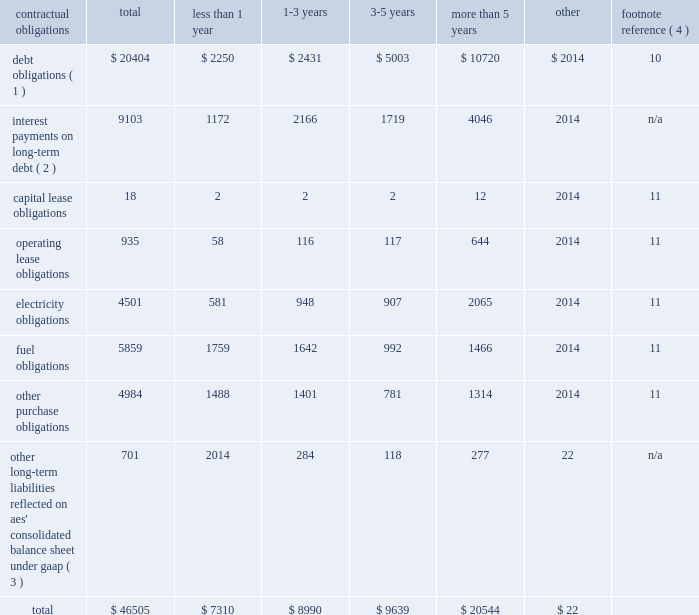2022 triggering our obligation to make payments under any financial guarantee , letter of credit or other credit support we have provided to or on behalf of such subsidiary ; 2022 causing us to record a loss in the event the lender forecloses on the assets ; and 2022 triggering defaults in our outstanding debt at the parent company .
For example , our senior secured credit facility and outstanding debt securities at the parent company include events of default for certain bankruptcy related events involving material subsidiaries .
In addition , our revolving credit agreement at the parent company includes events of default related to payment defaults and accelerations of outstanding debt of material subsidiaries .
Some of our subsidiaries are currently in default with respect to all or a portion of their outstanding indebtedness .
The total non-recourse debt classified as current in the accompanying consolidated balance sheets amounts to $ 2.2 billion .
The portion of current debt related to such defaults was $ 1 billion at december 31 , 2017 , all of which was non-recourse debt related to three subsidiaries 2014 alto maipo , aes puerto rico , and aes ilumina .
See note 10 2014debt in item 8 . 2014financial statements and supplementary data of this form 10-k for additional detail .
None of the subsidiaries that are currently in default are subsidiaries that met the applicable definition of materiality under aes' corporate debt agreements as of december 31 , 2017 in order for such defaults to trigger an event of default or permit acceleration under aes' indebtedness .
However , as a result of additional dispositions of assets , other significant reductions in asset carrying values or other matters in the future that may impact our financial position and results of operations or the financial position of the individual subsidiary , it is possible that one or more of these subsidiaries could fall within the definition of a "material subsidiary" and thereby upon an acceleration trigger an event of default and possible acceleration of the indebtedness under the parent company's outstanding debt securities .
A material subsidiary is defined in the company's senior secured revolving credit facility as any business that contributed 20% ( 20 % ) or more of the parent company's total cash distributions from businesses for the four most recently completed fiscal quarters .
As of december 31 , 2017 , none of the defaults listed above individually or in the aggregate results in or is at risk of triggering a cross-default under the recourse debt of the company .
Contractual obligations and parent company contingent contractual obligations a summary of our contractual obligations , commitments and other liabilities as of december 31 , 2017 is presented below and excludes any businesses classified as discontinued operations or held-for-sale ( in millions ) : contractual obligations total less than 1 year more than 5 years other footnote reference ( 4 ) debt obligations ( 1 ) $ 20404 $ 2250 $ 2431 $ 5003 $ 10720 $ 2014 10 interest payments on long-term debt ( 2 ) 9103 1172 2166 1719 4046 2014 n/a .
_____________________________ ( 1 ) includes recourse and non-recourse debt presented on the consolidated balance sheet .
These amounts exclude capital lease obligations which are included in the capital lease category .
( 2 ) interest payments are estimated based on final maturity dates of debt securities outstanding at december 31 , 2017 and do not reflect anticipated future refinancing , early redemptions or new debt issuances .
Variable rate interest obligations are estimated based on rates as of december 31 , 2017 .
( 3 ) these amounts do not include current liabilities on the consolidated balance sheet except for the current portion of uncertain tax obligations .
Noncurrent uncertain tax obligations are reflected in the "other" column of the table above as the company is not able to reasonably estimate the timing of the future payments .
In addition , these amounts do not include : ( 1 ) regulatory liabilities ( see note 9 2014regulatory assets and liabilities ) , ( 2 ) contingencies ( see note 12 2014contingencies ) , ( 3 ) pension and other postretirement employee benefit liabilities ( see note 13 2014benefit plans ) , ( 4 ) derivatives and incentive compensation ( see note 5 2014derivative instruments and hedging activities ) or ( 5 ) any taxes ( see note 20 2014income taxes ) except for uncertain tax obligations , as the company is not able to reasonably estimate the timing of future payments .
See the indicated notes to the consolidated financial statements included in item 8 of this form 10-k for additional information on the items excluded .
( 4 ) for further information see the note referenced below in item 8 . 2014financial statements and supplementary data of this form 10-k. .
What percentage of total contractual obligations , commitments and other liabilities as of december 31 , 2017 is composed of debt obligations? 
Computations: (20404 / 46505)
Answer: 0.43875. 2022 triggering our obligation to make payments under any financial guarantee , letter of credit or other credit support we have provided to or on behalf of such subsidiary ; 2022 causing us to record a loss in the event the lender forecloses on the assets ; and 2022 triggering defaults in our outstanding debt at the parent company .
For example , our senior secured credit facility and outstanding debt securities at the parent company include events of default for certain bankruptcy related events involving material subsidiaries .
In addition , our revolving credit agreement at the parent company includes events of default related to payment defaults and accelerations of outstanding debt of material subsidiaries .
Some of our subsidiaries are currently in default with respect to all or a portion of their outstanding indebtedness .
The total non-recourse debt classified as current in the accompanying consolidated balance sheets amounts to $ 2.2 billion .
The portion of current debt related to such defaults was $ 1 billion at december 31 , 2017 , all of which was non-recourse debt related to three subsidiaries 2014 alto maipo , aes puerto rico , and aes ilumina .
See note 10 2014debt in item 8 . 2014financial statements and supplementary data of this form 10-k for additional detail .
None of the subsidiaries that are currently in default are subsidiaries that met the applicable definition of materiality under aes' corporate debt agreements as of december 31 , 2017 in order for such defaults to trigger an event of default or permit acceleration under aes' indebtedness .
However , as a result of additional dispositions of assets , other significant reductions in asset carrying values or other matters in the future that may impact our financial position and results of operations or the financial position of the individual subsidiary , it is possible that one or more of these subsidiaries could fall within the definition of a "material subsidiary" and thereby upon an acceleration trigger an event of default and possible acceleration of the indebtedness under the parent company's outstanding debt securities .
A material subsidiary is defined in the company's senior secured revolving credit facility as any business that contributed 20% ( 20 % ) or more of the parent company's total cash distributions from businesses for the four most recently completed fiscal quarters .
As of december 31 , 2017 , none of the defaults listed above individually or in the aggregate results in or is at risk of triggering a cross-default under the recourse debt of the company .
Contractual obligations and parent company contingent contractual obligations a summary of our contractual obligations , commitments and other liabilities as of december 31 , 2017 is presented below and excludes any businesses classified as discontinued operations or held-for-sale ( in millions ) : contractual obligations total less than 1 year more than 5 years other footnote reference ( 4 ) debt obligations ( 1 ) $ 20404 $ 2250 $ 2431 $ 5003 $ 10720 $ 2014 10 interest payments on long-term debt ( 2 ) 9103 1172 2166 1719 4046 2014 n/a .
_____________________________ ( 1 ) includes recourse and non-recourse debt presented on the consolidated balance sheet .
These amounts exclude capital lease obligations which are included in the capital lease category .
( 2 ) interest payments are estimated based on final maturity dates of debt securities outstanding at december 31 , 2017 and do not reflect anticipated future refinancing , early redemptions or new debt issuances .
Variable rate interest obligations are estimated based on rates as of december 31 , 2017 .
( 3 ) these amounts do not include current liabilities on the consolidated balance sheet except for the current portion of uncertain tax obligations .
Noncurrent uncertain tax obligations are reflected in the "other" column of the table above as the company is not able to reasonably estimate the timing of the future payments .
In addition , these amounts do not include : ( 1 ) regulatory liabilities ( see note 9 2014regulatory assets and liabilities ) , ( 2 ) contingencies ( see note 12 2014contingencies ) , ( 3 ) pension and other postretirement employee benefit liabilities ( see note 13 2014benefit plans ) , ( 4 ) derivatives and incentive compensation ( see note 5 2014derivative instruments and hedging activities ) or ( 5 ) any taxes ( see note 20 2014income taxes ) except for uncertain tax obligations , as the company is not able to reasonably estimate the timing of future payments .
See the indicated notes to the consolidated financial statements included in item 8 of this form 10-k for additional information on the items excluded .
( 4 ) for further information see the note referenced below in item 8 . 2014financial statements and supplementary data of this form 10-k. .
What percent of debt obligations are long term? 
Computations: ((20404 - 2250) / 20404)
Answer: 0.88973. 